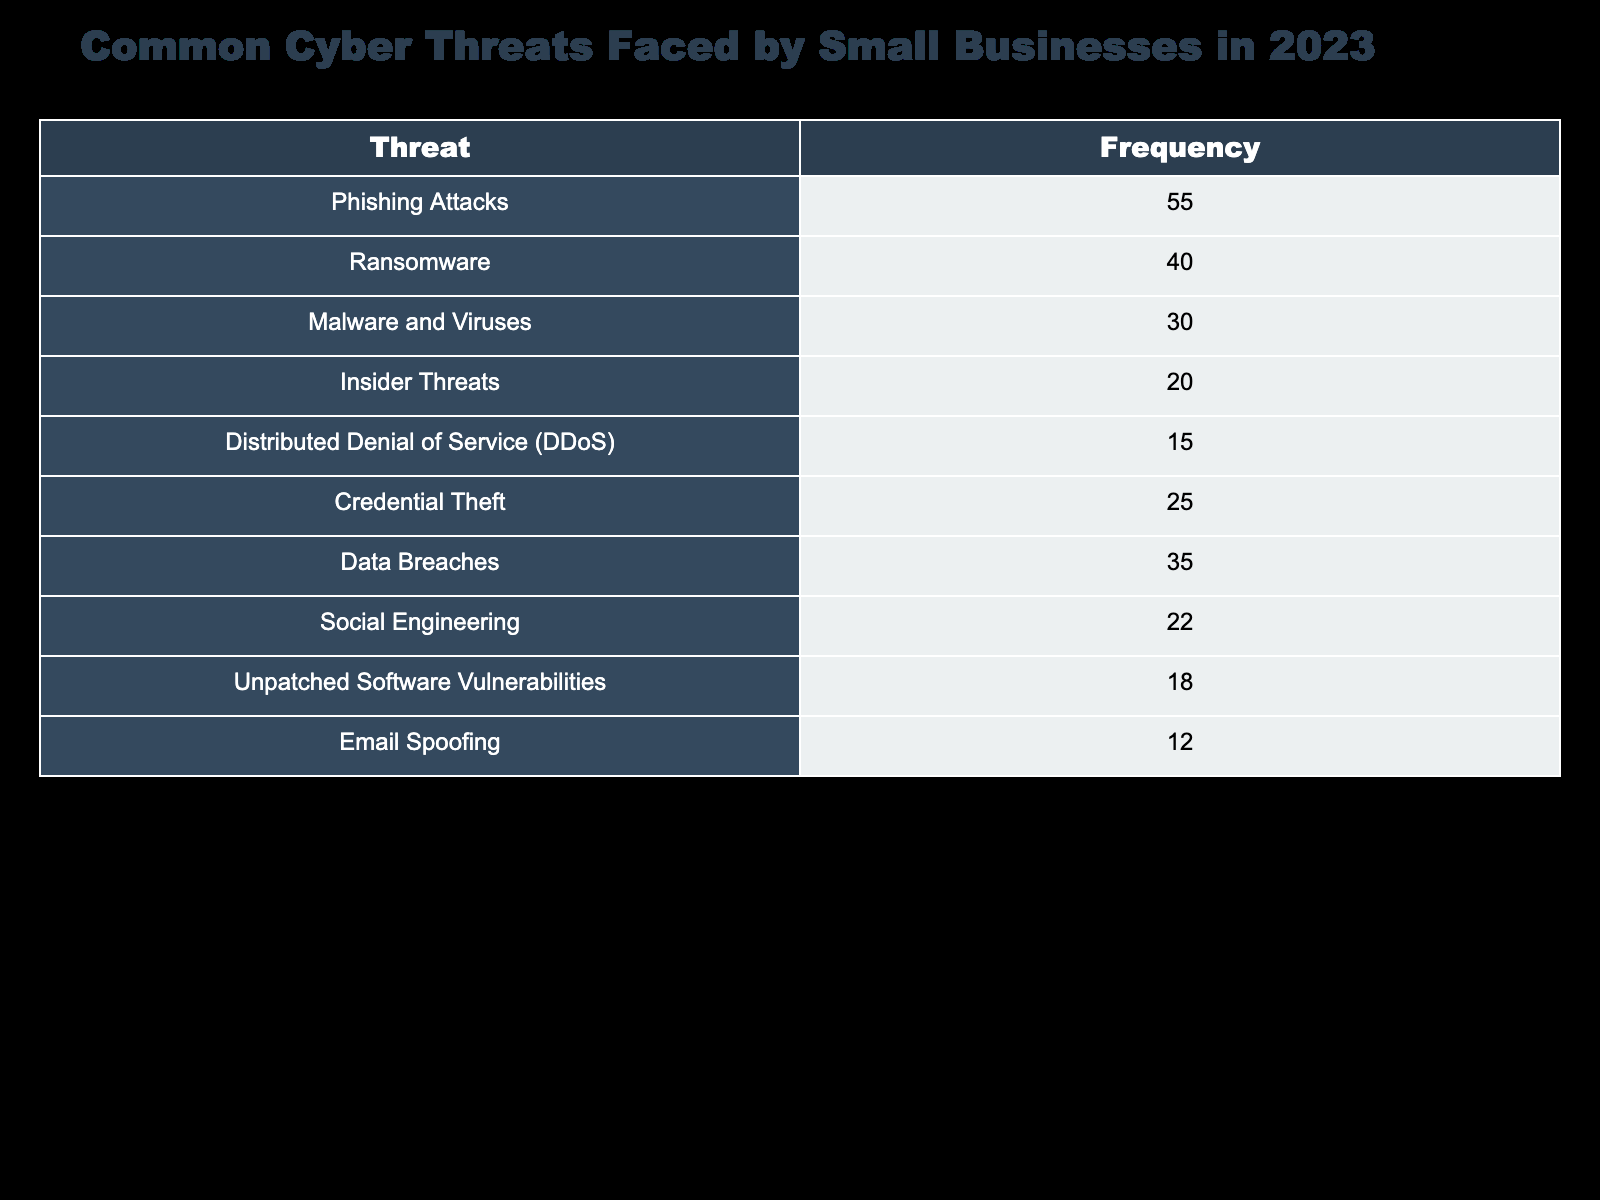what is the frequency of phishing attacks? The table lists 'Phishing Attacks' under the Threat column with a corresponding frequency of 55.
Answer: 55 which threat has the lowest frequency? By examining the Frequency column, 'Email Spoofing' has the lowest value at 12.
Answer: Email Spoofing how many threats have a frequency of 20 or higher? The threats with frequencies of 20 or higher are: Phishing Attacks (55), Ransomware (40), Malware and Viruses (30), Credential Theft (25), Data Breaches (35), Social Engineering (22), and Insider Threats (20), which sums to 7 threats.
Answer: 7 what is the total frequency of malware-related threats? The malware-related threats are Malware and Viruses (30) and Ransomware (40). Adding these values gives 30 + 40 = 70.
Answer: 70 is insider threats more frequent than unpatched software vulnerabilities? The frequency of Insider Threats is 20, while the frequency of Unpatched Software Vulnerabilities is 18. Since 20 is greater than 18, the answer is yes.
Answer: Yes what is the difference in frequency between the most common and least common threats? The most common threat is Phishing Attacks with a frequency of 55, while the least common is Email Spoofing with 12. The difference is calculated as 55 - 12 = 43.
Answer: 43 what percentage of the total threats is represented by DDoS attacks? To compute the percentage for DDoS, first sum all frequencies: (55 + 40 + 30 + 20 + 15 + 25 + 35 + 22 + 18 + 12) = 312. The frequency of DDoS is 15, so the percentage is (15 / 312) * 100 ≈ 4.81%.
Answer: 4.81% how many threats in the table are related to social engineering? The table lists Social Engineering as one of the threats with a frequency of 22. Since it is the only entry, only one threat is directly related to social engineering.
Answer: 1 which two threats combined have the highest frequency? By summing the frequencies of all threats and analyzing the pairs, we find that Phishing Attacks (55) and Ransomware (40) combined give the highest frequency of 95.
Answer: 95 